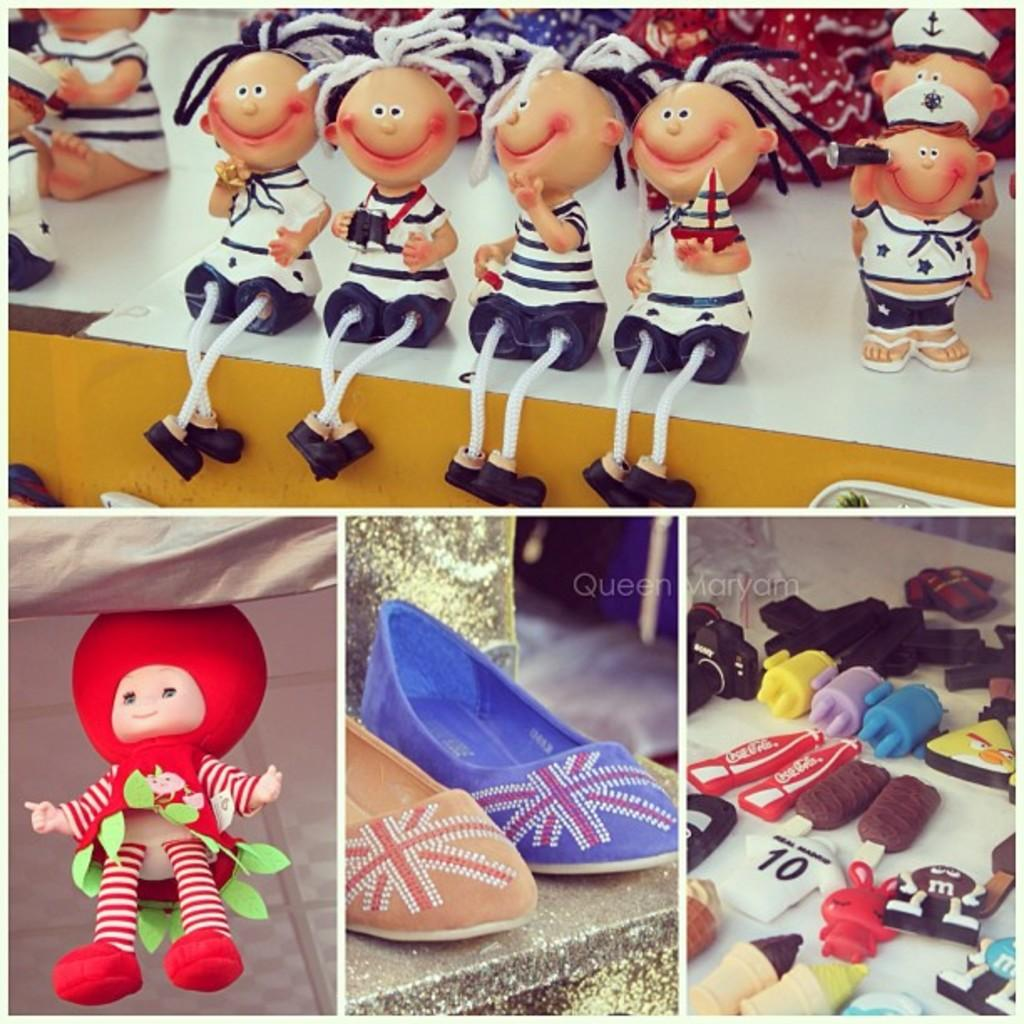What is placed on the platform in the image? There are shoes on a platform in the image. What other items can be seen in the image besides the shoes? There are toys and other objects present in the image. What type of lace is used to decorate the shoes in the image? There is no mention of lace or any decorative elements on the shoes in the image. 